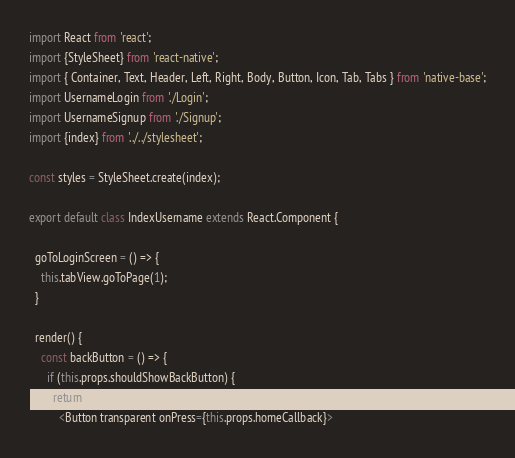Convert code to text. <code><loc_0><loc_0><loc_500><loc_500><_JavaScript_>import React from 'react';
import {StyleSheet} from 'react-native';
import { Container, Text, Header, Left, Right, Body, Button, Icon, Tab, Tabs } from 'native-base';
import UsernameLogin from './Login';
import UsernameSignup from './Signup';
import {index} from '../../stylesheet';

const styles = StyleSheet.create(index);

export default class IndexUsername extends React.Component {

  goToLoginScreen = () => {
    this.tabView.goToPage(1);
  }

  render() {
    const backButton = () => {
      if (this.props.shouldShowBackButton) {
        return (
          <Button transparent onPress={this.props.homeCallback}></code> 